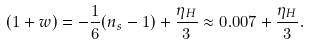<formula> <loc_0><loc_0><loc_500><loc_500>( 1 + w ) = - \frac { 1 } { 6 } ( n _ { s } - 1 ) + \frac { \eta _ { H } } { 3 } \approx 0 . 0 0 7 + \frac { \eta _ { H } } { 3 } .</formula> 